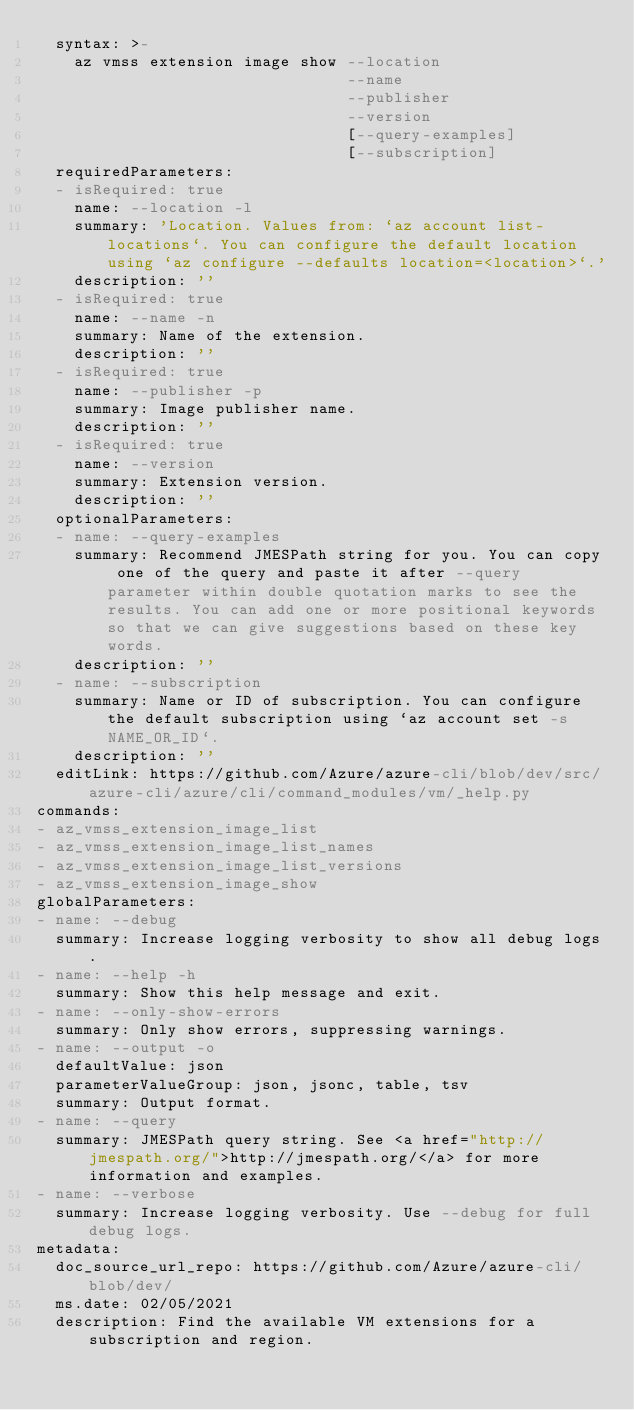<code> <loc_0><loc_0><loc_500><loc_500><_YAML_>  syntax: >-
    az vmss extension image show --location
                                 --name
                                 --publisher
                                 --version
                                 [--query-examples]
                                 [--subscription]
  requiredParameters:
  - isRequired: true
    name: --location -l
    summary: 'Location. Values from: `az account list-locations`. You can configure the default location using `az configure --defaults location=<location>`.'
    description: ''
  - isRequired: true
    name: --name -n
    summary: Name of the extension.
    description: ''
  - isRequired: true
    name: --publisher -p
    summary: Image publisher name.
    description: ''
  - isRequired: true
    name: --version
    summary: Extension version.
    description: ''
  optionalParameters:
  - name: --query-examples
    summary: Recommend JMESPath string for you. You can copy one of the query and paste it after --query parameter within double quotation marks to see the results. You can add one or more positional keywords so that we can give suggestions based on these key words.
    description: ''
  - name: --subscription
    summary: Name or ID of subscription. You can configure the default subscription using `az account set -s NAME_OR_ID`.
    description: ''
  editLink: https://github.com/Azure/azure-cli/blob/dev/src/azure-cli/azure/cli/command_modules/vm/_help.py
commands:
- az_vmss_extension_image_list
- az_vmss_extension_image_list_names
- az_vmss_extension_image_list_versions
- az_vmss_extension_image_show
globalParameters:
- name: --debug
  summary: Increase logging verbosity to show all debug logs.
- name: --help -h
  summary: Show this help message and exit.
- name: --only-show-errors
  summary: Only show errors, suppressing warnings.
- name: --output -o
  defaultValue: json
  parameterValueGroup: json, jsonc, table, tsv
  summary: Output format.
- name: --query
  summary: JMESPath query string. See <a href="http://jmespath.org/">http://jmespath.org/</a> for more information and examples.
- name: --verbose
  summary: Increase logging verbosity. Use --debug for full debug logs.
metadata:
  doc_source_url_repo: https://github.com/Azure/azure-cli/blob/dev/
  ms.date: 02/05/2021
  description: Find the available VM extensions for a subscription and region.
</code> 